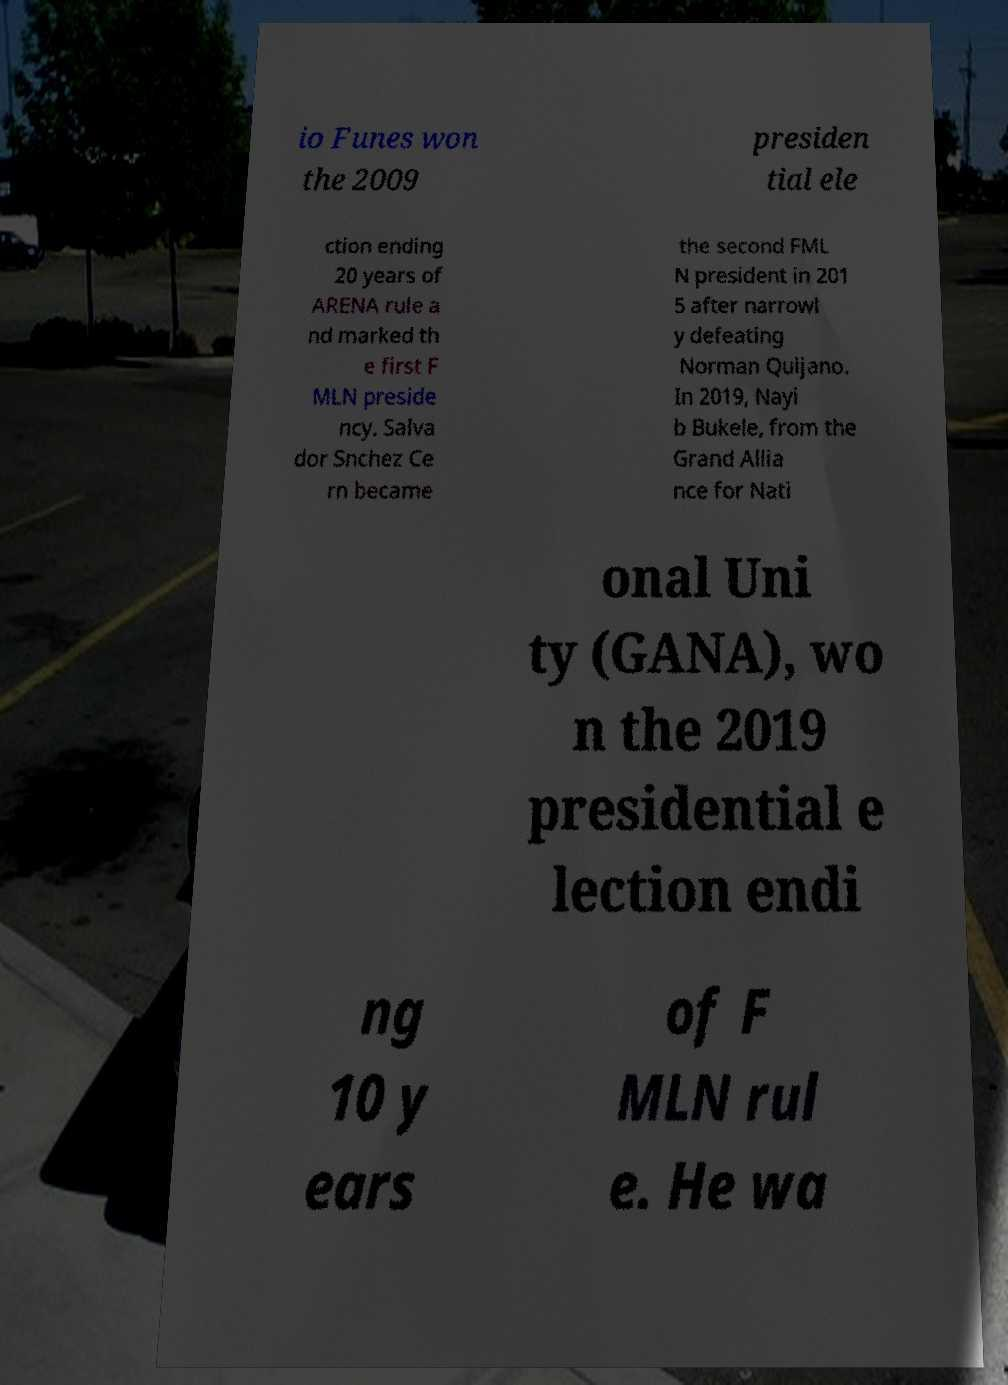Could you assist in decoding the text presented in this image and type it out clearly? io Funes won the 2009 presiden tial ele ction ending 20 years of ARENA rule a nd marked th e first F MLN preside ncy. Salva dor Snchez Ce rn became the second FML N president in 201 5 after narrowl y defeating Norman Quijano. In 2019, Nayi b Bukele, from the Grand Allia nce for Nati onal Uni ty (GANA), wo n the 2019 presidential e lection endi ng 10 y ears of F MLN rul e. He wa 